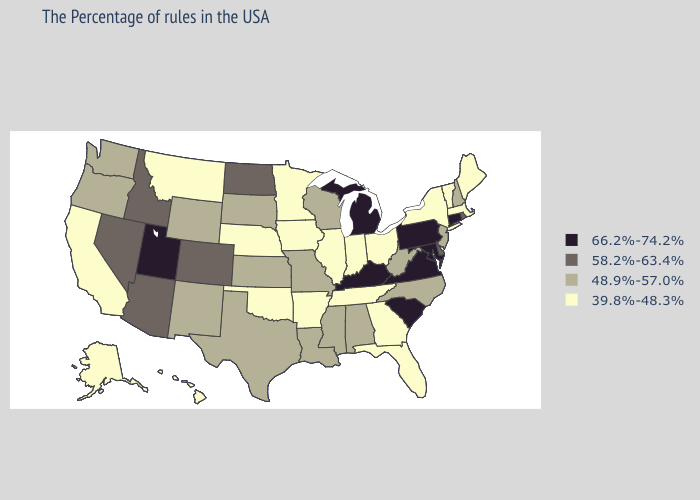Name the states that have a value in the range 39.8%-48.3%?
Concise answer only. Maine, Massachusetts, Vermont, New York, Ohio, Florida, Georgia, Indiana, Tennessee, Illinois, Arkansas, Minnesota, Iowa, Nebraska, Oklahoma, Montana, California, Alaska, Hawaii. Name the states that have a value in the range 66.2%-74.2%?
Concise answer only. Connecticut, Maryland, Pennsylvania, Virginia, South Carolina, Michigan, Kentucky, Utah. Which states have the lowest value in the South?
Keep it brief. Florida, Georgia, Tennessee, Arkansas, Oklahoma. Among the states that border Delaware , which have the lowest value?
Give a very brief answer. New Jersey. What is the value of Rhode Island?
Quick response, please. 58.2%-63.4%. What is the lowest value in the West?
Quick response, please. 39.8%-48.3%. What is the value of Minnesota?
Keep it brief. 39.8%-48.3%. What is the value of Louisiana?
Give a very brief answer. 48.9%-57.0%. What is the value of Wisconsin?
Concise answer only. 48.9%-57.0%. What is the lowest value in the West?
Short answer required. 39.8%-48.3%. Name the states that have a value in the range 58.2%-63.4%?
Answer briefly. Rhode Island, Delaware, North Dakota, Colorado, Arizona, Idaho, Nevada. Among the states that border California , does Nevada have the lowest value?
Concise answer only. No. Name the states that have a value in the range 48.9%-57.0%?
Concise answer only. New Hampshire, New Jersey, North Carolina, West Virginia, Alabama, Wisconsin, Mississippi, Louisiana, Missouri, Kansas, Texas, South Dakota, Wyoming, New Mexico, Washington, Oregon. How many symbols are there in the legend?
Give a very brief answer. 4. Does Michigan have the highest value in the MidWest?
Concise answer only. Yes. 